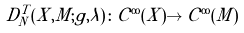<formula> <loc_0><loc_0><loc_500><loc_500>D _ { N } ^ { T } ( X , M ; g , \lambda ) \colon \mathcal { C } ^ { \infty } ( X ) \to \mathcal { C } ^ { \infty } ( M )</formula> 